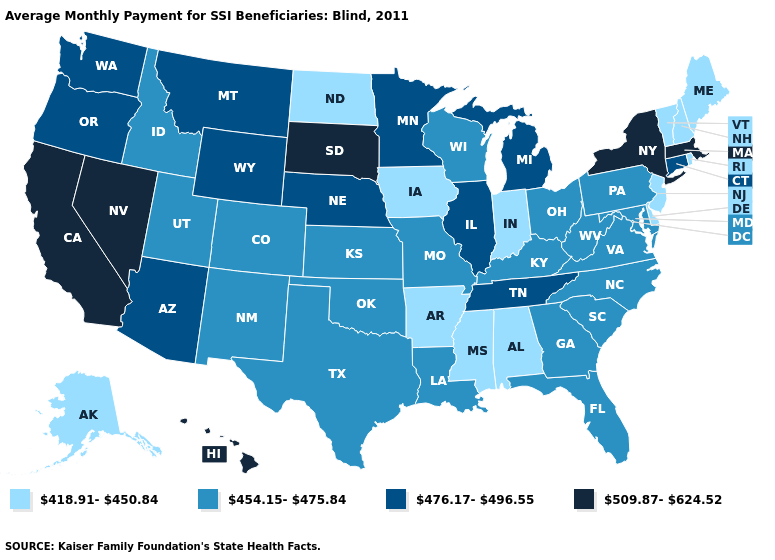Does Florida have a lower value than Alabama?
Answer briefly. No. Name the states that have a value in the range 509.87-624.52?
Write a very short answer. California, Hawaii, Massachusetts, Nevada, New York, South Dakota. What is the value of Arkansas?
Give a very brief answer. 418.91-450.84. What is the value of Delaware?
Give a very brief answer. 418.91-450.84. What is the value of Connecticut?
Concise answer only. 476.17-496.55. Does Maryland have the highest value in the USA?
Keep it brief. No. What is the lowest value in states that border Louisiana?
Give a very brief answer. 418.91-450.84. What is the highest value in the MidWest ?
Write a very short answer. 509.87-624.52. Among the states that border Maryland , which have the lowest value?
Give a very brief answer. Delaware. Does Louisiana have a higher value than North Carolina?
Concise answer only. No. What is the highest value in the Northeast ?
Give a very brief answer. 509.87-624.52. Name the states that have a value in the range 418.91-450.84?
Concise answer only. Alabama, Alaska, Arkansas, Delaware, Indiana, Iowa, Maine, Mississippi, New Hampshire, New Jersey, North Dakota, Rhode Island, Vermont. What is the value of Nevada?
Concise answer only. 509.87-624.52. What is the value of Nebraska?
Be succinct. 476.17-496.55. What is the lowest value in the USA?
Give a very brief answer. 418.91-450.84. 